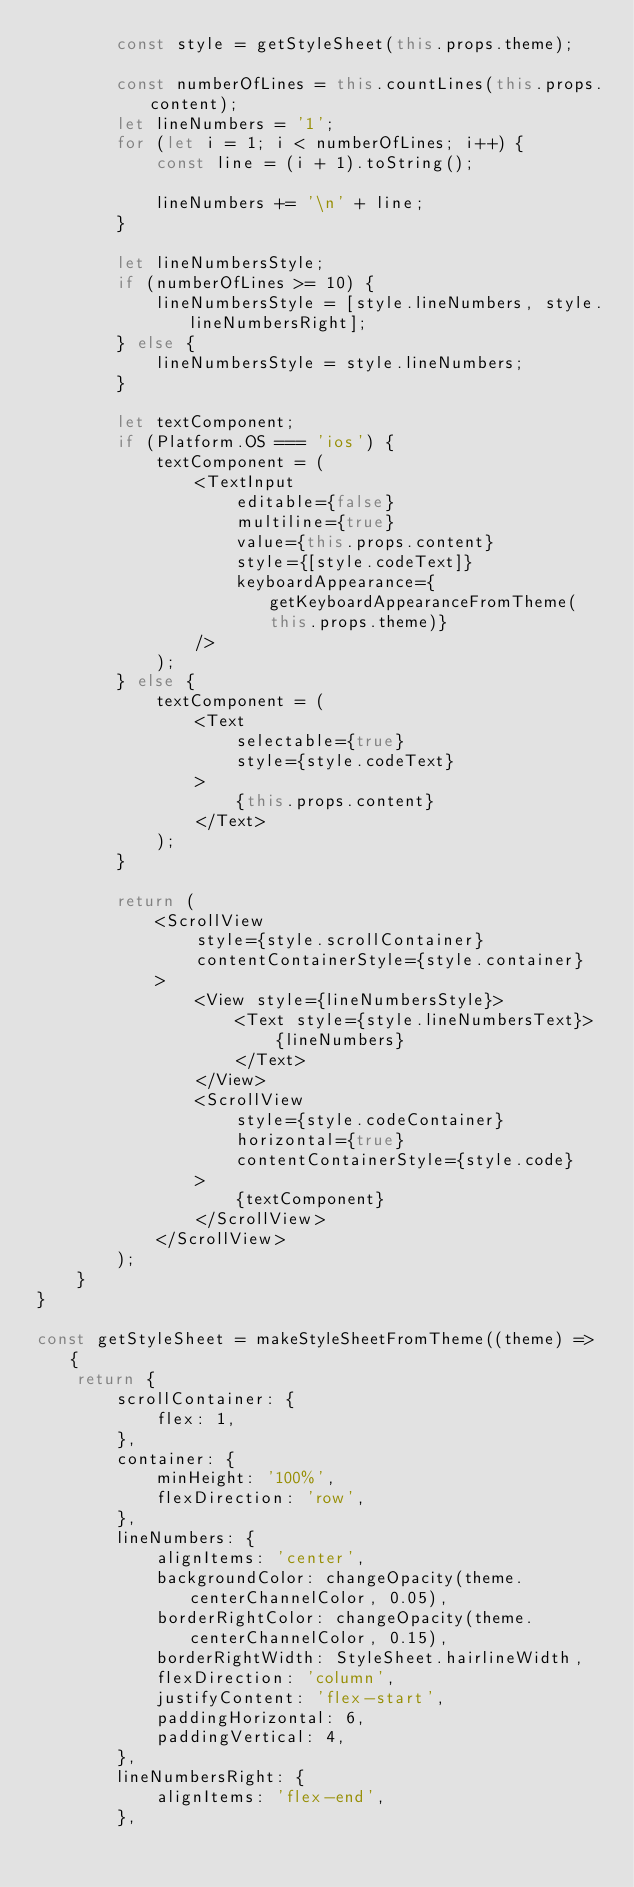<code> <loc_0><loc_0><loc_500><loc_500><_JavaScript_>        const style = getStyleSheet(this.props.theme);

        const numberOfLines = this.countLines(this.props.content);
        let lineNumbers = '1';
        for (let i = 1; i < numberOfLines; i++) {
            const line = (i + 1).toString();

            lineNumbers += '\n' + line;
        }

        let lineNumbersStyle;
        if (numberOfLines >= 10) {
            lineNumbersStyle = [style.lineNumbers, style.lineNumbersRight];
        } else {
            lineNumbersStyle = style.lineNumbers;
        }

        let textComponent;
        if (Platform.OS === 'ios') {
            textComponent = (
                <TextInput
                    editable={false}
                    multiline={true}
                    value={this.props.content}
                    style={[style.codeText]}
                    keyboardAppearance={getKeyboardAppearanceFromTheme(this.props.theme)}
                />
            );
        } else {
            textComponent = (
                <Text
                    selectable={true}
                    style={style.codeText}
                >
                    {this.props.content}
                </Text>
            );
        }

        return (
            <ScrollView
                style={style.scrollContainer}
                contentContainerStyle={style.container}
            >
                <View style={lineNumbersStyle}>
                    <Text style={style.lineNumbersText}>
                        {lineNumbers}
                    </Text>
                </View>
                <ScrollView
                    style={style.codeContainer}
                    horizontal={true}
                    contentContainerStyle={style.code}
                >
                    {textComponent}
                </ScrollView>
            </ScrollView>
        );
    }
}

const getStyleSheet = makeStyleSheetFromTheme((theme) => {
    return {
        scrollContainer: {
            flex: 1,
        },
        container: {
            minHeight: '100%',
            flexDirection: 'row',
        },
        lineNumbers: {
            alignItems: 'center',
            backgroundColor: changeOpacity(theme.centerChannelColor, 0.05),
            borderRightColor: changeOpacity(theme.centerChannelColor, 0.15),
            borderRightWidth: StyleSheet.hairlineWidth,
            flexDirection: 'column',
            justifyContent: 'flex-start',
            paddingHorizontal: 6,
            paddingVertical: 4,
        },
        lineNumbersRight: {
            alignItems: 'flex-end',
        },</code> 